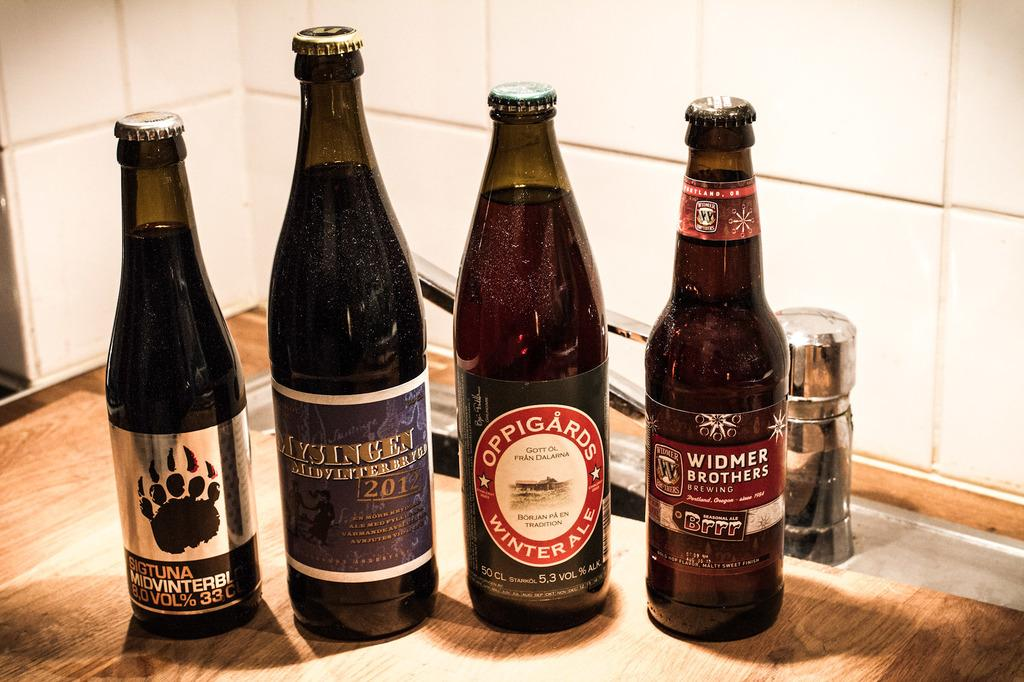<image>
Present a compact description of the photo's key features. A bottle of Widmer Brothers beer sits with three other kinds of bottles. 